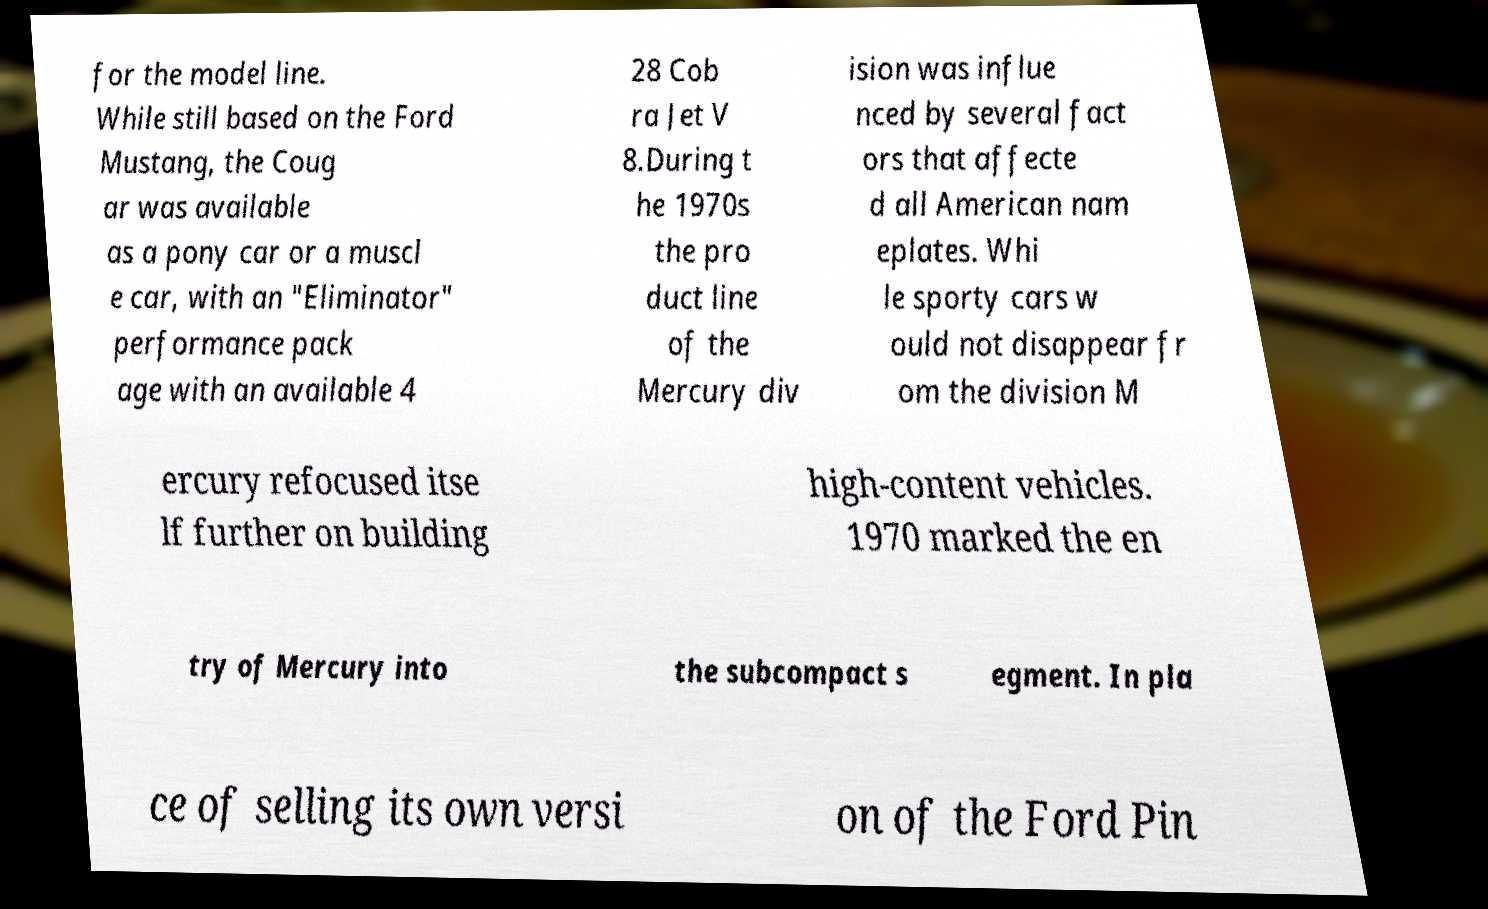Can you accurately transcribe the text from the provided image for me? for the model line. While still based on the Ford Mustang, the Coug ar was available as a pony car or a muscl e car, with an "Eliminator" performance pack age with an available 4 28 Cob ra Jet V 8.During t he 1970s the pro duct line of the Mercury div ision was influe nced by several fact ors that affecte d all American nam eplates. Whi le sporty cars w ould not disappear fr om the division M ercury refocused itse lf further on building high-content vehicles. 1970 marked the en try of Mercury into the subcompact s egment. In pla ce of selling its own versi on of the Ford Pin 